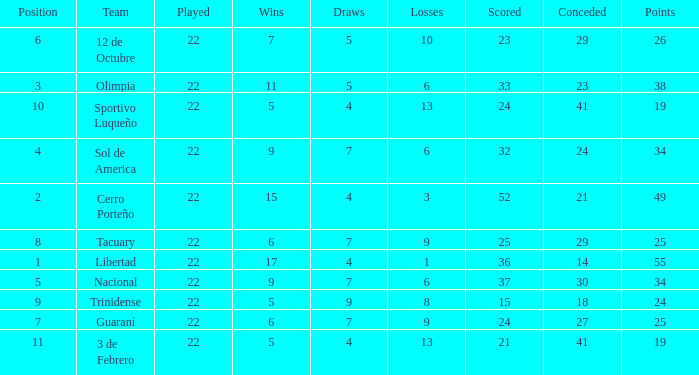What is the value scored when there were 19 points for the team 3 de Febrero? 21.0. 